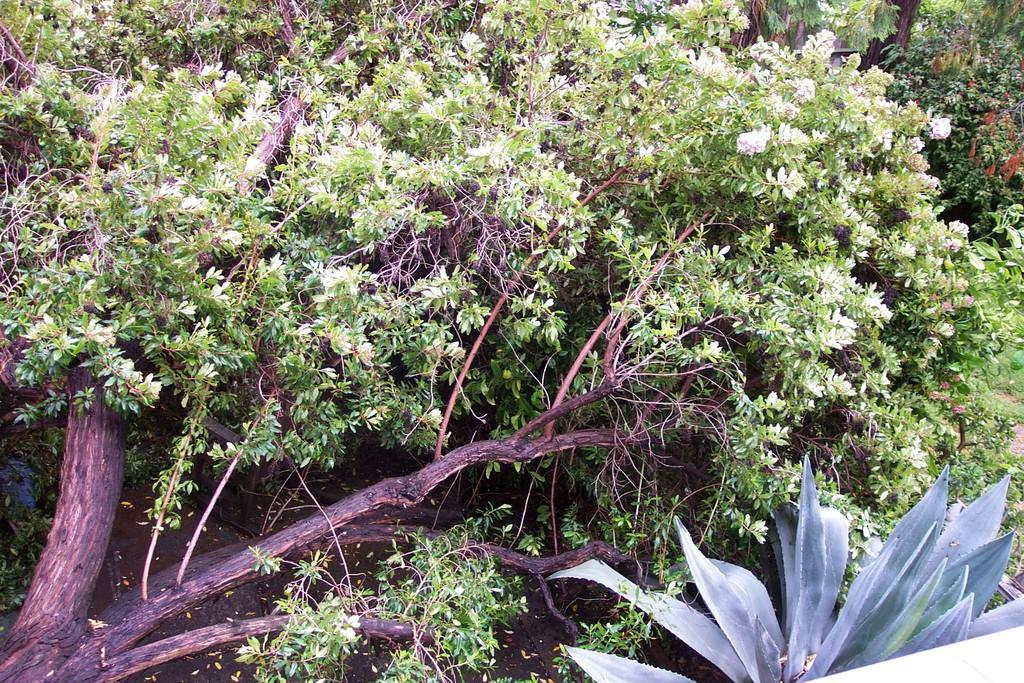What type of vegetation can be seen in the image? There are trees and plants in the image. Can you describe the trees in the image? The facts provided do not give specific details about the trees, but we can confirm that trees are present. What else can be seen in the image besides the trees and plants? The facts provided do not mention any other objects or subjects in the image. What is the average income of the trees in the image? There is no information about the income of the trees in the image, as trees do not have income. How often do the plants in the image cough? Plants do not cough, so this question cannot be answered. 